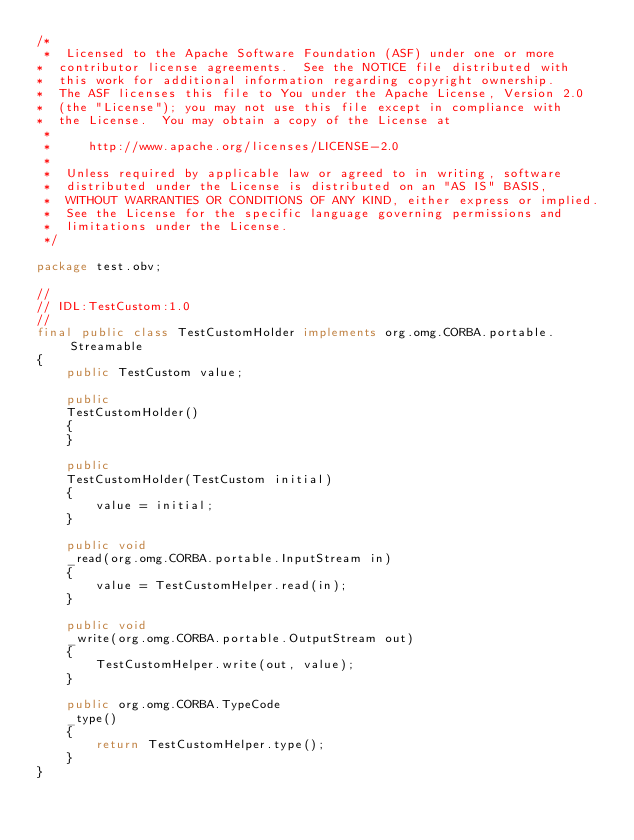<code> <loc_0><loc_0><loc_500><loc_500><_Java_>/*
 *  Licensed to the Apache Software Foundation (ASF) under one or more
*  contributor license agreements.  See the NOTICE file distributed with
*  this work for additional information regarding copyright ownership.
*  The ASF licenses this file to You under the Apache License, Version 2.0
*  (the "License"); you may not use this file except in compliance with
*  the License.  You may obtain a copy of the License at
 *
 *     http://www.apache.org/licenses/LICENSE-2.0
 *
 *  Unless required by applicable law or agreed to in writing, software
 *  distributed under the License is distributed on an "AS IS" BASIS,
 *  WITHOUT WARRANTIES OR CONDITIONS OF ANY KIND, either express or implied.
 *  See the License for the specific language governing permissions and
 *  limitations under the License.
 */

package test.obv;

//
// IDL:TestCustom:1.0
//
final public class TestCustomHolder implements org.omg.CORBA.portable.Streamable
{
    public TestCustom value;

    public
    TestCustomHolder()
    {
    }

    public
    TestCustomHolder(TestCustom initial)
    {
        value = initial;
    }

    public void
    _read(org.omg.CORBA.portable.InputStream in)
    {
        value = TestCustomHelper.read(in);
    }

    public void
    _write(org.omg.CORBA.portable.OutputStream out)
    {
        TestCustomHelper.write(out, value);
    }

    public org.omg.CORBA.TypeCode
    _type()
    {
        return TestCustomHelper.type();
    }
}
</code> 